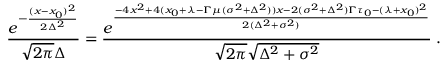Convert formula to latex. <formula><loc_0><loc_0><loc_500><loc_500>{ \frac { e ^ { - { \frac { ( x - x _ { 0 } ) ^ { 2 } } { 2 \Delta ^ { 2 } } } } } { \sqrt { 2 \pi } \Delta } } = { \frac { e ^ { \frac { - 4 x ^ { 2 } + 4 ( x _ { 0 } + \lambda - \Gamma \mu ( \sigma ^ { 2 } + \Delta ^ { 2 } ) ) x - 2 ( \sigma ^ { 2 } + \Delta ^ { 2 } ) \Gamma \tau _ { 0 } - ( \lambda + x _ { 0 } ) ^ { 2 } } { 2 ( \Delta ^ { 2 } + \sigma ^ { 2 } ) } } } { \sqrt { 2 \pi } \sqrt { \Delta ^ { 2 } + \sigma ^ { 2 } } } } \, .</formula> 